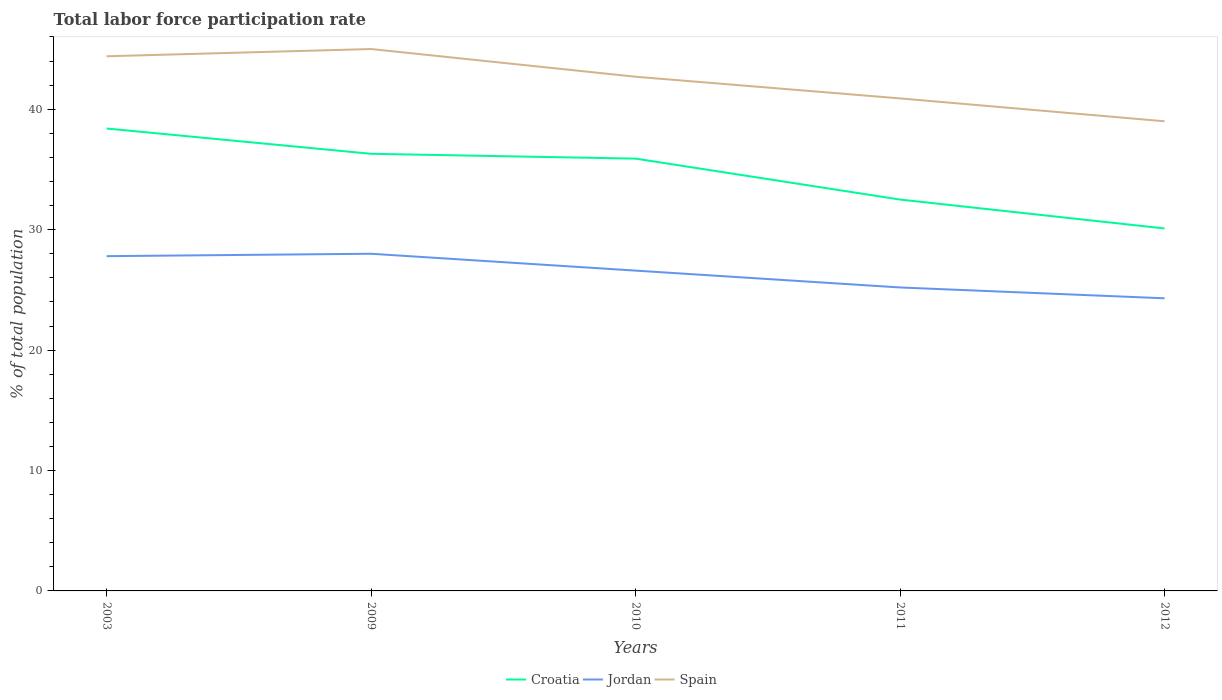Across all years, what is the maximum total labor force participation rate in Spain?
Your response must be concise. 39. What is the total total labor force participation rate in Spain in the graph?
Make the answer very short. 1.9. What is the difference between the highest and the second highest total labor force participation rate in Jordan?
Give a very brief answer. 3.7. What is the difference between the highest and the lowest total labor force participation rate in Spain?
Your answer should be very brief. 3. What is the difference between two consecutive major ticks on the Y-axis?
Your response must be concise. 10. Does the graph contain any zero values?
Provide a short and direct response. No. Does the graph contain grids?
Offer a terse response. No. How many legend labels are there?
Your answer should be very brief. 3. What is the title of the graph?
Ensure brevity in your answer.  Total labor force participation rate. What is the label or title of the X-axis?
Give a very brief answer. Years. What is the label or title of the Y-axis?
Provide a short and direct response. % of total population. What is the % of total population in Croatia in 2003?
Offer a terse response. 38.4. What is the % of total population in Jordan in 2003?
Your response must be concise. 27.8. What is the % of total population of Spain in 2003?
Offer a very short reply. 44.4. What is the % of total population in Croatia in 2009?
Offer a very short reply. 36.3. What is the % of total population of Jordan in 2009?
Keep it short and to the point. 28. What is the % of total population of Spain in 2009?
Keep it short and to the point. 45. What is the % of total population of Croatia in 2010?
Provide a short and direct response. 35.9. What is the % of total population in Jordan in 2010?
Your response must be concise. 26.6. What is the % of total population of Spain in 2010?
Offer a terse response. 42.7. What is the % of total population in Croatia in 2011?
Make the answer very short. 32.5. What is the % of total population of Jordan in 2011?
Provide a short and direct response. 25.2. What is the % of total population in Spain in 2011?
Keep it short and to the point. 40.9. What is the % of total population in Croatia in 2012?
Provide a short and direct response. 30.1. What is the % of total population in Jordan in 2012?
Offer a terse response. 24.3. Across all years, what is the maximum % of total population in Croatia?
Keep it short and to the point. 38.4. Across all years, what is the maximum % of total population of Spain?
Keep it short and to the point. 45. Across all years, what is the minimum % of total population in Croatia?
Provide a short and direct response. 30.1. Across all years, what is the minimum % of total population of Jordan?
Your response must be concise. 24.3. What is the total % of total population of Croatia in the graph?
Give a very brief answer. 173.2. What is the total % of total population in Jordan in the graph?
Keep it short and to the point. 131.9. What is the total % of total population of Spain in the graph?
Provide a succinct answer. 212. What is the difference between the % of total population in Croatia in 2003 and that in 2009?
Provide a succinct answer. 2.1. What is the difference between the % of total population in Jordan in 2003 and that in 2009?
Your answer should be very brief. -0.2. What is the difference between the % of total population of Spain in 2003 and that in 2009?
Offer a very short reply. -0.6. What is the difference between the % of total population of Spain in 2003 and that in 2010?
Offer a very short reply. 1.7. What is the difference between the % of total population of Jordan in 2003 and that in 2011?
Offer a terse response. 2.6. What is the difference between the % of total population in Spain in 2003 and that in 2011?
Your response must be concise. 3.5. What is the difference between the % of total population in Croatia in 2003 and that in 2012?
Give a very brief answer. 8.3. What is the difference between the % of total population in Spain in 2003 and that in 2012?
Provide a short and direct response. 5.4. What is the difference between the % of total population of Spain in 2009 and that in 2011?
Ensure brevity in your answer.  4.1. What is the difference between the % of total population in Croatia in 2010 and that in 2011?
Provide a succinct answer. 3.4. What is the difference between the % of total population in Spain in 2010 and that in 2011?
Provide a short and direct response. 1.8. What is the difference between the % of total population of Croatia in 2010 and that in 2012?
Keep it short and to the point. 5.8. What is the difference between the % of total population of Jordan in 2010 and that in 2012?
Keep it short and to the point. 2.3. What is the difference between the % of total population of Spain in 2010 and that in 2012?
Offer a terse response. 3.7. What is the difference between the % of total population of Croatia in 2011 and that in 2012?
Your answer should be compact. 2.4. What is the difference between the % of total population in Croatia in 2003 and the % of total population in Jordan in 2009?
Ensure brevity in your answer.  10.4. What is the difference between the % of total population in Jordan in 2003 and the % of total population in Spain in 2009?
Give a very brief answer. -17.2. What is the difference between the % of total population of Jordan in 2003 and the % of total population of Spain in 2010?
Your response must be concise. -14.9. What is the difference between the % of total population in Croatia in 2003 and the % of total population in Jordan in 2011?
Make the answer very short. 13.2. What is the difference between the % of total population in Jordan in 2003 and the % of total population in Spain in 2011?
Make the answer very short. -13.1. What is the difference between the % of total population in Croatia in 2009 and the % of total population in Jordan in 2010?
Your answer should be compact. 9.7. What is the difference between the % of total population of Croatia in 2009 and the % of total population of Spain in 2010?
Offer a very short reply. -6.4. What is the difference between the % of total population of Jordan in 2009 and the % of total population of Spain in 2010?
Your response must be concise. -14.7. What is the difference between the % of total population of Jordan in 2009 and the % of total population of Spain in 2011?
Offer a very short reply. -12.9. What is the difference between the % of total population of Croatia in 2009 and the % of total population of Spain in 2012?
Keep it short and to the point. -2.7. What is the difference between the % of total population of Croatia in 2010 and the % of total population of Jordan in 2011?
Offer a terse response. 10.7. What is the difference between the % of total population of Croatia in 2010 and the % of total population of Spain in 2011?
Ensure brevity in your answer.  -5. What is the difference between the % of total population in Jordan in 2010 and the % of total population in Spain in 2011?
Make the answer very short. -14.3. What is the difference between the % of total population in Croatia in 2010 and the % of total population in Jordan in 2012?
Your answer should be very brief. 11.6. What is the difference between the % of total population in Jordan in 2010 and the % of total population in Spain in 2012?
Your answer should be compact. -12.4. What is the difference between the % of total population in Croatia in 2011 and the % of total population in Jordan in 2012?
Offer a very short reply. 8.2. What is the average % of total population of Croatia per year?
Keep it short and to the point. 34.64. What is the average % of total population of Jordan per year?
Offer a terse response. 26.38. What is the average % of total population in Spain per year?
Provide a succinct answer. 42.4. In the year 2003, what is the difference between the % of total population of Croatia and % of total population of Jordan?
Give a very brief answer. 10.6. In the year 2003, what is the difference between the % of total population in Jordan and % of total population in Spain?
Offer a very short reply. -16.6. In the year 2009, what is the difference between the % of total population in Croatia and % of total population in Jordan?
Provide a succinct answer. 8.3. In the year 2009, what is the difference between the % of total population of Croatia and % of total population of Spain?
Keep it short and to the point. -8.7. In the year 2009, what is the difference between the % of total population of Jordan and % of total population of Spain?
Your response must be concise. -17. In the year 2010, what is the difference between the % of total population of Croatia and % of total population of Jordan?
Offer a very short reply. 9.3. In the year 2010, what is the difference between the % of total population in Jordan and % of total population in Spain?
Keep it short and to the point. -16.1. In the year 2011, what is the difference between the % of total population of Jordan and % of total population of Spain?
Provide a succinct answer. -15.7. In the year 2012, what is the difference between the % of total population of Croatia and % of total population of Jordan?
Provide a short and direct response. 5.8. In the year 2012, what is the difference between the % of total population of Croatia and % of total population of Spain?
Your answer should be compact. -8.9. In the year 2012, what is the difference between the % of total population in Jordan and % of total population in Spain?
Provide a short and direct response. -14.7. What is the ratio of the % of total population in Croatia in 2003 to that in 2009?
Provide a succinct answer. 1.06. What is the ratio of the % of total population of Jordan in 2003 to that in 2009?
Your response must be concise. 0.99. What is the ratio of the % of total population in Spain in 2003 to that in 2009?
Offer a very short reply. 0.99. What is the ratio of the % of total population in Croatia in 2003 to that in 2010?
Keep it short and to the point. 1.07. What is the ratio of the % of total population of Jordan in 2003 to that in 2010?
Provide a succinct answer. 1.05. What is the ratio of the % of total population of Spain in 2003 to that in 2010?
Keep it short and to the point. 1.04. What is the ratio of the % of total population in Croatia in 2003 to that in 2011?
Offer a terse response. 1.18. What is the ratio of the % of total population of Jordan in 2003 to that in 2011?
Make the answer very short. 1.1. What is the ratio of the % of total population of Spain in 2003 to that in 2011?
Provide a short and direct response. 1.09. What is the ratio of the % of total population in Croatia in 2003 to that in 2012?
Your response must be concise. 1.28. What is the ratio of the % of total population in Jordan in 2003 to that in 2012?
Make the answer very short. 1.14. What is the ratio of the % of total population in Spain in 2003 to that in 2012?
Give a very brief answer. 1.14. What is the ratio of the % of total population in Croatia in 2009 to that in 2010?
Your answer should be compact. 1.01. What is the ratio of the % of total population of Jordan in 2009 to that in 2010?
Offer a terse response. 1.05. What is the ratio of the % of total population in Spain in 2009 to that in 2010?
Give a very brief answer. 1.05. What is the ratio of the % of total population in Croatia in 2009 to that in 2011?
Provide a short and direct response. 1.12. What is the ratio of the % of total population in Spain in 2009 to that in 2011?
Give a very brief answer. 1.1. What is the ratio of the % of total population of Croatia in 2009 to that in 2012?
Keep it short and to the point. 1.21. What is the ratio of the % of total population in Jordan in 2009 to that in 2012?
Offer a very short reply. 1.15. What is the ratio of the % of total population of Spain in 2009 to that in 2012?
Offer a terse response. 1.15. What is the ratio of the % of total population of Croatia in 2010 to that in 2011?
Offer a very short reply. 1.1. What is the ratio of the % of total population of Jordan in 2010 to that in 2011?
Make the answer very short. 1.06. What is the ratio of the % of total population in Spain in 2010 to that in 2011?
Your response must be concise. 1.04. What is the ratio of the % of total population of Croatia in 2010 to that in 2012?
Keep it short and to the point. 1.19. What is the ratio of the % of total population of Jordan in 2010 to that in 2012?
Provide a short and direct response. 1.09. What is the ratio of the % of total population in Spain in 2010 to that in 2012?
Ensure brevity in your answer.  1.09. What is the ratio of the % of total population of Croatia in 2011 to that in 2012?
Provide a short and direct response. 1.08. What is the ratio of the % of total population of Spain in 2011 to that in 2012?
Offer a terse response. 1.05. What is the difference between the highest and the second highest % of total population in Croatia?
Provide a short and direct response. 2.1. What is the difference between the highest and the second highest % of total population in Jordan?
Your response must be concise. 0.2. What is the difference between the highest and the second highest % of total population of Spain?
Give a very brief answer. 0.6. What is the difference between the highest and the lowest % of total population of Jordan?
Ensure brevity in your answer.  3.7. 